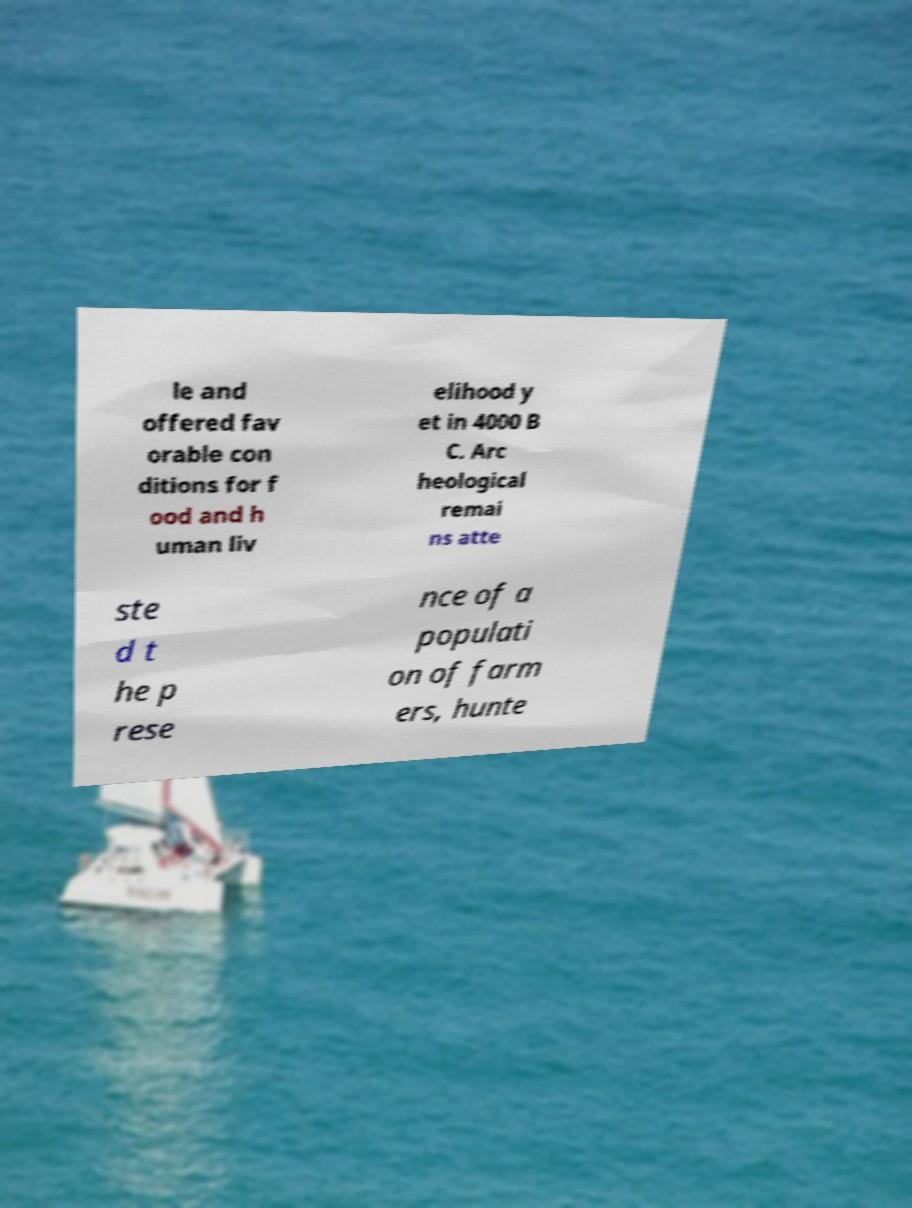I need the written content from this picture converted into text. Can you do that? le and offered fav orable con ditions for f ood and h uman liv elihood y et in 4000 B C. Arc heological remai ns atte ste d t he p rese nce of a populati on of farm ers, hunte 